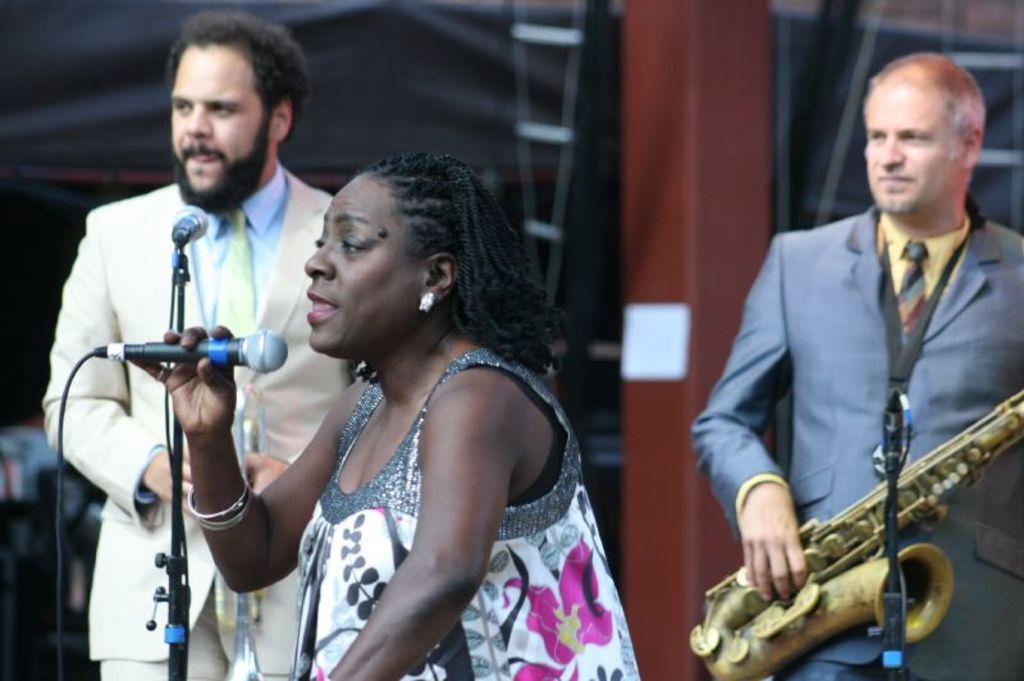Please provide a concise description of this image. In the picture we can see two men, one woman, two men are standing, and one man is holding a musical instrument and one woman is singing a song in the microphone. In the background we can see a brown pillar. 